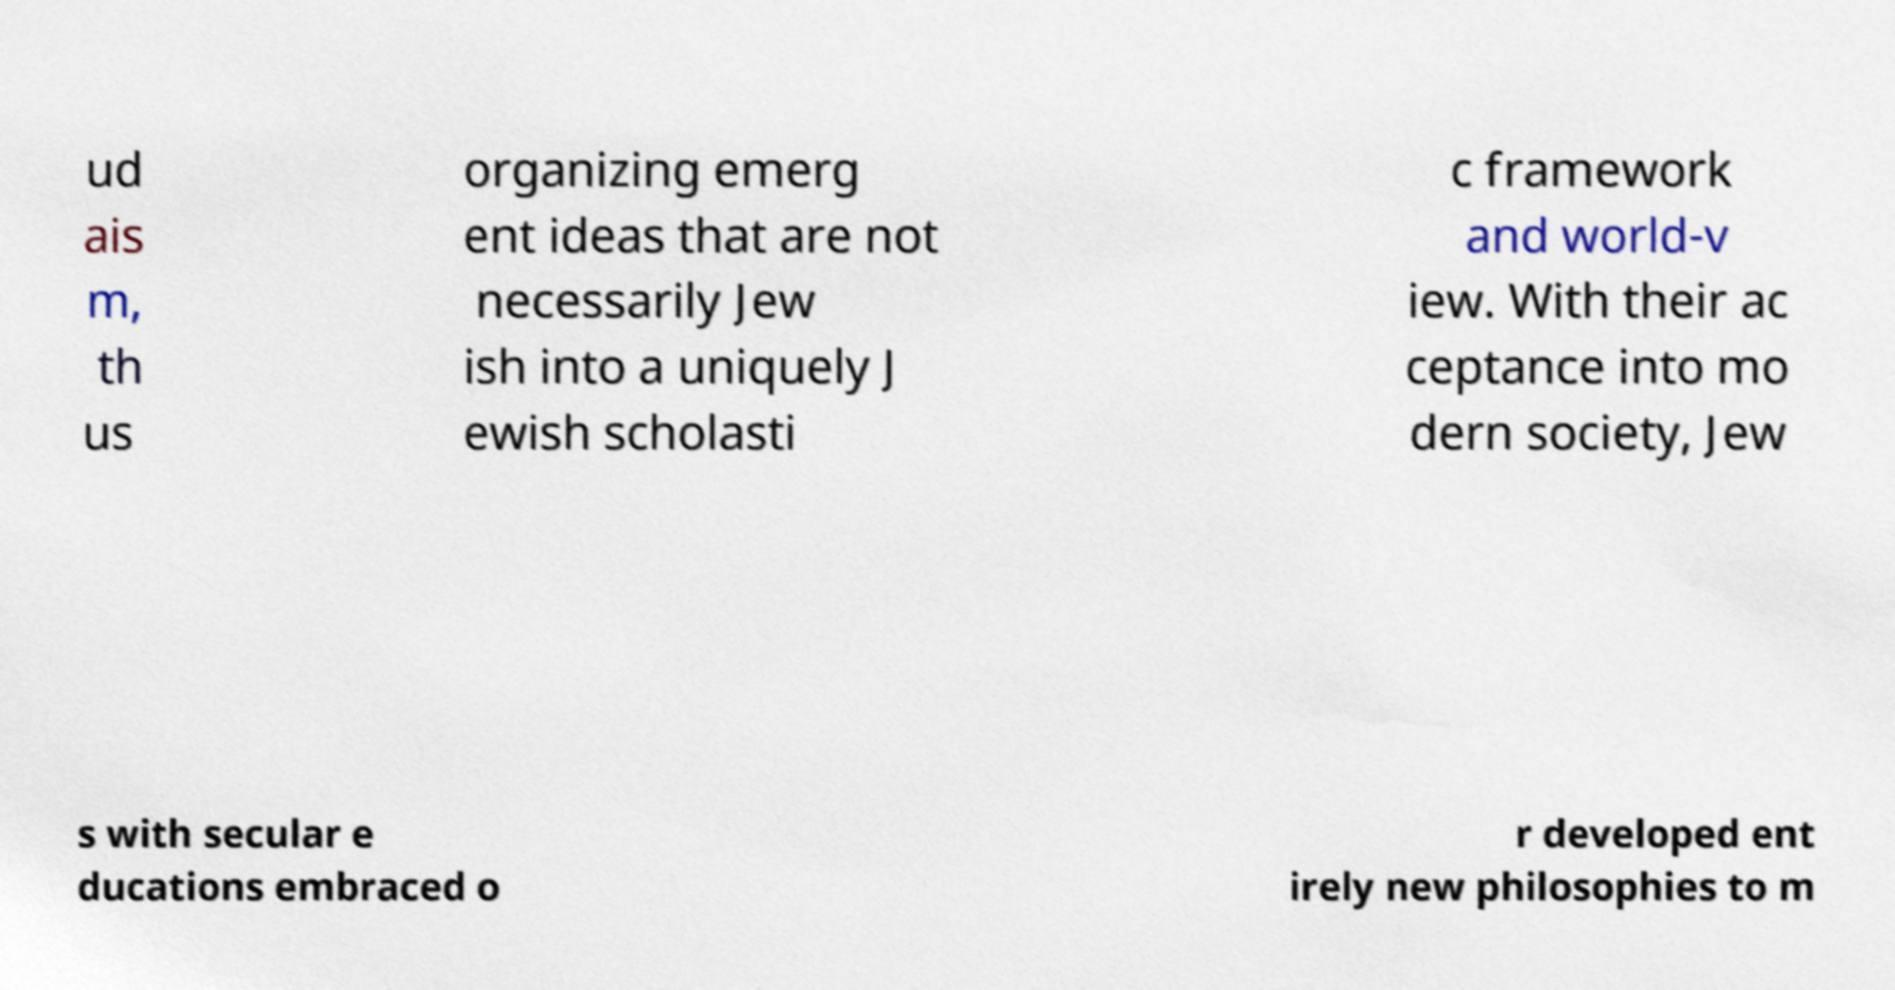Please read and relay the text visible in this image. What does it say? ud ais m, th us organizing emerg ent ideas that are not necessarily Jew ish into a uniquely J ewish scholasti c framework and world-v iew. With their ac ceptance into mo dern society, Jew s with secular e ducations embraced o r developed ent irely new philosophies to m 